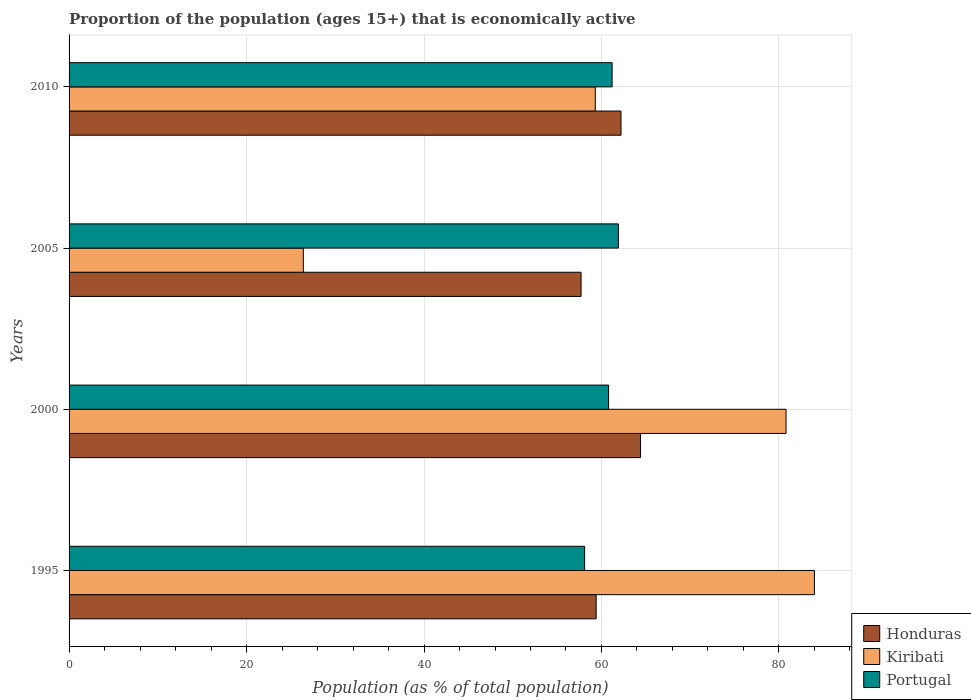How many different coloured bars are there?
Ensure brevity in your answer.  3. How many groups of bars are there?
Your answer should be very brief. 4. Are the number of bars per tick equal to the number of legend labels?
Offer a terse response. Yes. Are the number of bars on each tick of the Y-axis equal?
Give a very brief answer. Yes. How many bars are there on the 4th tick from the top?
Provide a short and direct response. 3. What is the label of the 1st group of bars from the top?
Make the answer very short. 2010. In how many cases, is the number of bars for a given year not equal to the number of legend labels?
Ensure brevity in your answer.  0. What is the proportion of the population that is economically active in Honduras in 1995?
Ensure brevity in your answer.  59.4. Across all years, what is the maximum proportion of the population that is economically active in Portugal?
Provide a short and direct response. 61.9. Across all years, what is the minimum proportion of the population that is economically active in Honduras?
Provide a short and direct response. 57.7. In which year was the proportion of the population that is economically active in Portugal maximum?
Give a very brief answer. 2005. In which year was the proportion of the population that is economically active in Portugal minimum?
Provide a short and direct response. 1995. What is the total proportion of the population that is economically active in Kiribati in the graph?
Ensure brevity in your answer.  250.5. What is the difference between the proportion of the population that is economically active in Kiribati in 1995 and that in 2010?
Provide a succinct answer. 24.7. What is the difference between the proportion of the population that is economically active in Honduras in 2010 and the proportion of the population that is economically active in Kiribati in 2005?
Keep it short and to the point. 35.8. What is the average proportion of the population that is economically active in Kiribati per year?
Provide a short and direct response. 62.63. In the year 2010, what is the difference between the proportion of the population that is economically active in Kiribati and proportion of the population that is economically active in Portugal?
Ensure brevity in your answer.  -1.9. What is the ratio of the proportion of the population that is economically active in Portugal in 1995 to that in 2010?
Keep it short and to the point. 0.95. Is the proportion of the population that is economically active in Honduras in 1995 less than that in 2010?
Give a very brief answer. Yes. What is the difference between the highest and the second highest proportion of the population that is economically active in Portugal?
Make the answer very short. 0.7. What is the difference between the highest and the lowest proportion of the population that is economically active in Honduras?
Provide a succinct answer. 6.7. Is the sum of the proportion of the population that is economically active in Honduras in 1995 and 2005 greater than the maximum proportion of the population that is economically active in Kiribati across all years?
Make the answer very short. Yes. What does the 2nd bar from the top in 2010 represents?
Keep it short and to the point. Kiribati. What does the 3rd bar from the bottom in 2000 represents?
Offer a very short reply. Portugal. What is the difference between two consecutive major ticks on the X-axis?
Ensure brevity in your answer.  20. Are the values on the major ticks of X-axis written in scientific E-notation?
Give a very brief answer. No. Does the graph contain any zero values?
Your answer should be compact. No. Does the graph contain grids?
Offer a very short reply. Yes. What is the title of the graph?
Provide a succinct answer. Proportion of the population (ages 15+) that is economically active. Does "Zambia" appear as one of the legend labels in the graph?
Ensure brevity in your answer.  No. What is the label or title of the X-axis?
Offer a very short reply. Population (as % of total population). What is the label or title of the Y-axis?
Give a very brief answer. Years. What is the Population (as % of total population) of Honduras in 1995?
Keep it short and to the point. 59.4. What is the Population (as % of total population) of Kiribati in 1995?
Offer a very short reply. 84. What is the Population (as % of total population) of Portugal in 1995?
Your response must be concise. 58.1. What is the Population (as % of total population) of Honduras in 2000?
Give a very brief answer. 64.4. What is the Population (as % of total population) of Kiribati in 2000?
Offer a very short reply. 80.8. What is the Population (as % of total population) of Portugal in 2000?
Make the answer very short. 60.8. What is the Population (as % of total population) of Honduras in 2005?
Offer a very short reply. 57.7. What is the Population (as % of total population) of Kiribati in 2005?
Ensure brevity in your answer.  26.4. What is the Population (as % of total population) in Portugal in 2005?
Make the answer very short. 61.9. What is the Population (as % of total population) of Honduras in 2010?
Make the answer very short. 62.2. What is the Population (as % of total population) of Kiribati in 2010?
Provide a succinct answer. 59.3. What is the Population (as % of total population) of Portugal in 2010?
Offer a very short reply. 61.2. Across all years, what is the maximum Population (as % of total population) of Honduras?
Give a very brief answer. 64.4. Across all years, what is the maximum Population (as % of total population) in Portugal?
Keep it short and to the point. 61.9. Across all years, what is the minimum Population (as % of total population) in Honduras?
Offer a terse response. 57.7. Across all years, what is the minimum Population (as % of total population) in Kiribati?
Make the answer very short. 26.4. Across all years, what is the minimum Population (as % of total population) in Portugal?
Keep it short and to the point. 58.1. What is the total Population (as % of total population) of Honduras in the graph?
Provide a short and direct response. 243.7. What is the total Population (as % of total population) of Kiribati in the graph?
Provide a succinct answer. 250.5. What is the total Population (as % of total population) of Portugal in the graph?
Ensure brevity in your answer.  242. What is the difference between the Population (as % of total population) in Kiribati in 1995 and that in 2000?
Provide a succinct answer. 3.2. What is the difference between the Population (as % of total population) of Honduras in 1995 and that in 2005?
Give a very brief answer. 1.7. What is the difference between the Population (as % of total population) in Kiribati in 1995 and that in 2005?
Give a very brief answer. 57.6. What is the difference between the Population (as % of total population) of Honduras in 1995 and that in 2010?
Offer a very short reply. -2.8. What is the difference between the Population (as % of total population) of Kiribati in 1995 and that in 2010?
Provide a succinct answer. 24.7. What is the difference between the Population (as % of total population) in Portugal in 1995 and that in 2010?
Your answer should be compact. -3.1. What is the difference between the Population (as % of total population) in Kiribati in 2000 and that in 2005?
Your answer should be very brief. 54.4. What is the difference between the Population (as % of total population) in Kiribati in 2000 and that in 2010?
Ensure brevity in your answer.  21.5. What is the difference between the Population (as % of total population) in Kiribati in 2005 and that in 2010?
Your answer should be very brief. -32.9. What is the difference between the Population (as % of total population) in Honduras in 1995 and the Population (as % of total population) in Kiribati in 2000?
Ensure brevity in your answer.  -21.4. What is the difference between the Population (as % of total population) of Kiribati in 1995 and the Population (as % of total population) of Portugal in 2000?
Offer a terse response. 23.2. What is the difference between the Population (as % of total population) of Honduras in 1995 and the Population (as % of total population) of Kiribati in 2005?
Offer a terse response. 33. What is the difference between the Population (as % of total population) in Kiribati in 1995 and the Population (as % of total population) in Portugal in 2005?
Offer a very short reply. 22.1. What is the difference between the Population (as % of total population) in Kiribati in 1995 and the Population (as % of total population) in Portugal in 2010?
Give a very brief answer. 22.8. What is the difference between the Population (as % of total population) of Honduras in 2000 and the Population (as % of total population) of Kiribati in 2005?
Keep it short and to the point. 38. What is the difference between the Population (as % of total population) in Honduras in 2000 and the Population (as % of total population) in Kiribati in 2010?
Give a very brief answer. 5.1. What is the difference between the Population (as % of total population) of Kiribati in 2000 and the Population (as % of total population) of Portugal in 2010?
Give a very brief answer. 19.6. What is the difference between the Population (as % of total population) of Honduras in 2005 and the Population (as % of total population) of Kiribati in 2010?
Your response must be concise. -1.6. What is the difference between the Population (as % of total population) in Kiribati in 2005 and the Population (as % of total population) in Portugal in 2010?
Your response must be concise. -34.8. What is the average Population (as % of total population) in Honduras per year?
Your response must be concise. 60.92. What is the average Population (as % of total population) in Kiribati per year?
Your answer should be very brief. 62.62. What is the average Population (as % of total population) in Portugal per year?
Offer a terse response. 60.5. In the year 1995, what is the difference between the Population (as % of total population) in Honduras and Population (as % of total population) in Kiribati?
Give a very brief answer. -24.6. In the year 1995, what is the difference between the Population (as % of total population) of Kiribati and Population (as % of total population) of Portugal?
Your response must be concise. 25.9. In the year 2000, what is the difference between the Population (as % of total population) of Honduras and Population (as % of total population) of Kiribati?
Ensure brevity in your answer.  -16.4. In the year 2005, what is the difference between the Population (as % of total population) in Honduras and Population (as % of total population) in Kiribati?
Ensure brevity in your answer.  31.3. In the year 2005, what is the difference between the Population (as % of total population) of Honduras and Population (as % of total population) of Portugal?
Give a very brief answer. -4.2. In the year 2005, what is the difference between the Population (as % of total population) in Kiribati and Population (as % of total population) in Portugal?
Offer a terse response. -35.5. In the year 2010, what is the difference between the Population (as % of total population) of Kiribati and Population (as % of total population) of Portugal?
Your answer should be compact. -1.9. What is the ratio of the Population (as % of total population) of Honduras in 1995 to that in 2000?
Your answer should be very brief. 0.92. What is the ratio of the Population (as % of total population) of Kiribati in 1995 to that in 2000?
Your answer should be compact. 1.04. What is the ratio of the Population (as % of total population) in Portugal in 1995 to that in 2000?
Ensure brevity in your answer.  0.96. What is the ratio of the Population (as % of total population) in Honduras in 1995 to that in 2005?
Give a very brief answer. 1.03. What is the ratio of the Population (as % of total population) in Kiribati in 1995 to that in 2005?
Provide a succinct answer. 3.18. What is the ratio of the Population (as % of total population) of Portugal in 1995 to that in 2005?
Give a very brief answer. 0.94. What is the ratio of the Population (as % of total population) of Honduras in 1995 to that in 2010?
Your answer should be compact. 0.95. What is the ratio of the Population (as % of total population) of Kiribati in 1995 to that in 2010?
Ensure brevity in your answer.  1.42. What is the ratio of the Population (as % of total population) of Portugal in 1995 to that in 2010?
Provide a succinct answer. 0.95. What is the ratio of the Population (as % of total population) of Honduras in 2000 to that in 2005?
Offer a very short reply. 1.12. What is the ratio of the Population (as % of total population) in Kiribati in 2000 to that in 2005?
Ensure brevity in your answer.  3.06. What is the ratio of the Population (as % of total population) in Portugal in 2000 to that in 2005?
Ensure brevity in your answer.  0.98. What is the ratio of the Population (as % of total population) of Honduras in 2000 to that in 2010?
Provide a succinct answer. 1.04. What is the ratio of the Population (as % of total population) in Kiribati in 2000 to that in 2010?
Ensure brevity in your answer.  1.36. What is the ratio of the Population (as % of total population) in Portugal in 2000 to that in 2010?
Your answer should be compact. 0.99. What is the ratio of the Population (as % of total population) in Honduras in 2005 to that in 2010?
Your answer should be compact. 0.93. What is the ratio of the Population (as % of total population) of Kiribati in 2005 to that in 2010?
Your answer should be compact. 0.45. What is the ratio of the Population (as % of total population) in Portugal in 2005 to that in 2010?
Keep it short and to the point. 1.01. What is the difference between the highest and the second highest Population (as % of total population) of Honduras?
Your answer should be very brief. 2.2. What is the difference between the highest and the lowest Population (as % of total population) of Honduras?
Make the answer very short. 6.7. What is the difference between the highest and the lowest Population (as % of total population) of Kiribati?
Offer a very short reply. 57.6. 